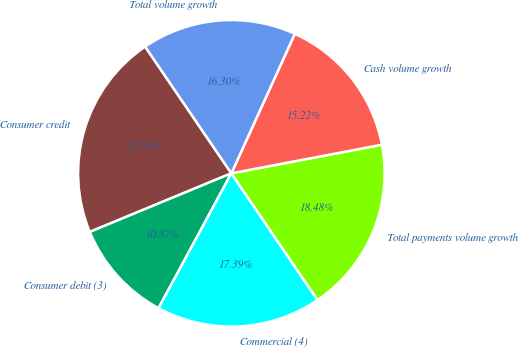<chart> <loc_0><loc_0><loc_500><loc_500><pie_chart><fcel>Consumer credit<fcel>Consumer debit (3)<fcel>Commercial (4)<fcel>Total payments volume growth<fcel>Cash volume growth<fcel>Total volume growth<nl><fcel>21.74%<fcel>10.87%<fcel>17.39%<fcel>18.48%<fcel>15.22%<fcel>16.3%<nl></chart> 